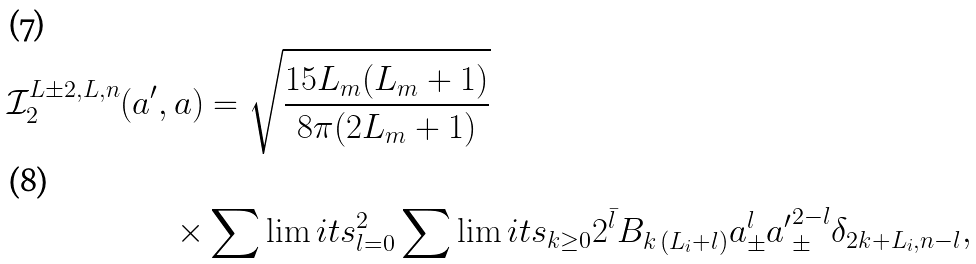Convert formula to latex. <formula><loc_0><loc_0><loc_500><loc_500>\mathcal { I } ^ { L \pm 2 , L , n } _ { 2 } ( a ^ { \prime } , a ) & = \sqrt { \frac { 1 5 L _ { m } ( L _ { m } + 1 ) } { 8 \pi ( 2 L _ { m } + 1 ) } } \\ \times & \sum \lim i t s _ { l = 0 } ^ { 2 } \sum \lim i t s _ { k \geq 0 } 2 ^ { \bar { l } } B _ { k \, ( L _ { i } + l ) } a _ { \pm } ^ { l } { a ^ { \prime } } _ { \pm } ^ { 2 - l } \delta _ { 2 k + L _ { i } , n - l } ,</formula> 